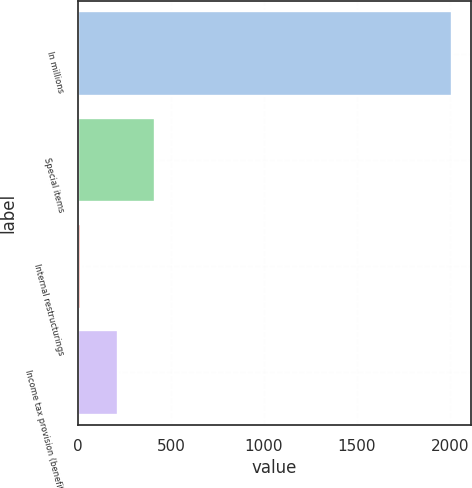Convert chart to OTSL. <chart><loc_0><loc_0><loc_500><loc_500><bar_chart><fcel>In millions<fcel>Special items<fcel>Internal restructurings<fcel>Income tax provision (benefit)<nl><fcel>2012<fcel>413.6<fcel>14<fcel>213.8<nl></chart> 